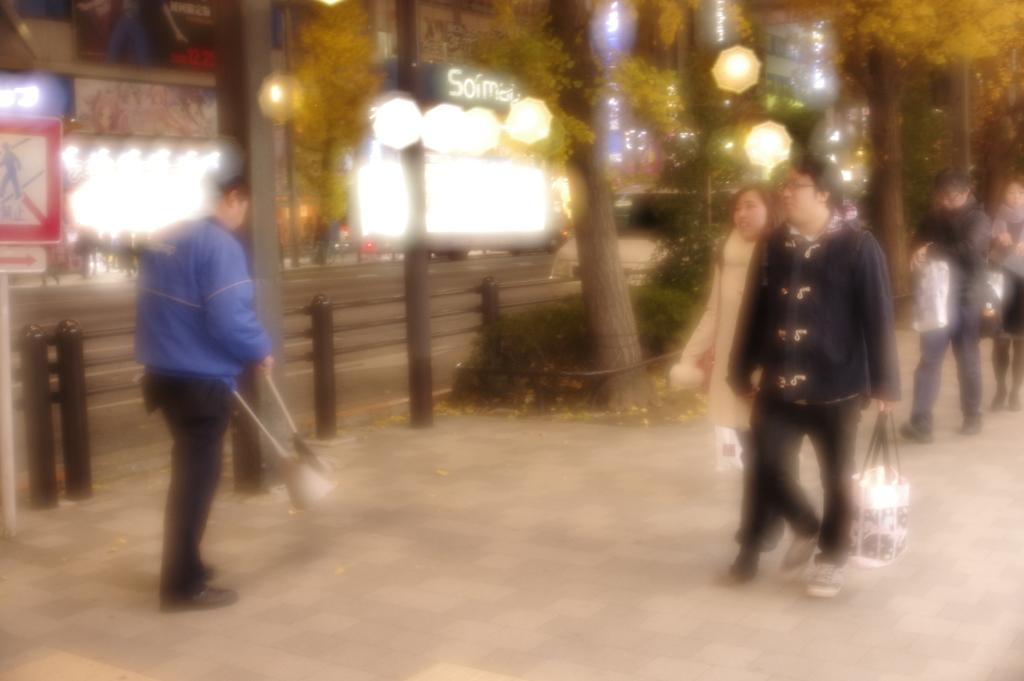What is located on the left side of the image? There is a man on the left side of the image. What can be seen on the right side of the image? There are people walking on the right side of the image. What type of natural elements are in the middle of the image? There are trees in the middle of the image. What else is present in the middle of the image besides trees? There are lights and buildings with boards in the middle of the image. Can you see any waves in the image? There are no waves present in the image. Is there a turkey visible in the image? There is no turkey present in the image. 